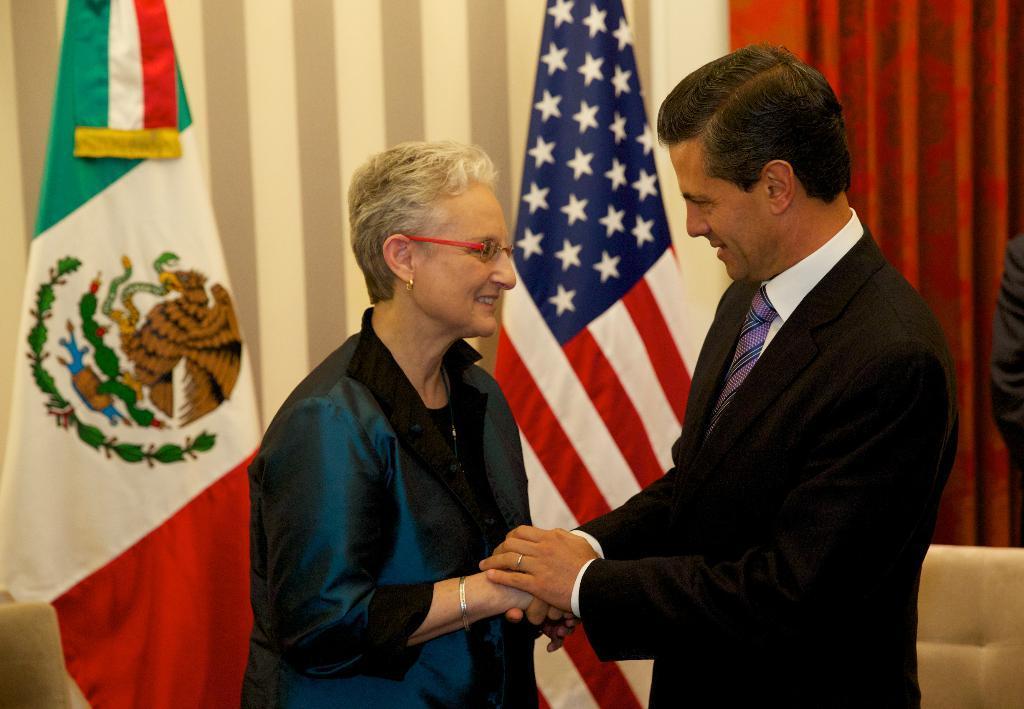Can you describe this image briefly? In this image we can see a man holding the woman hands. In the background we can see two flags and also a red color curtain. 